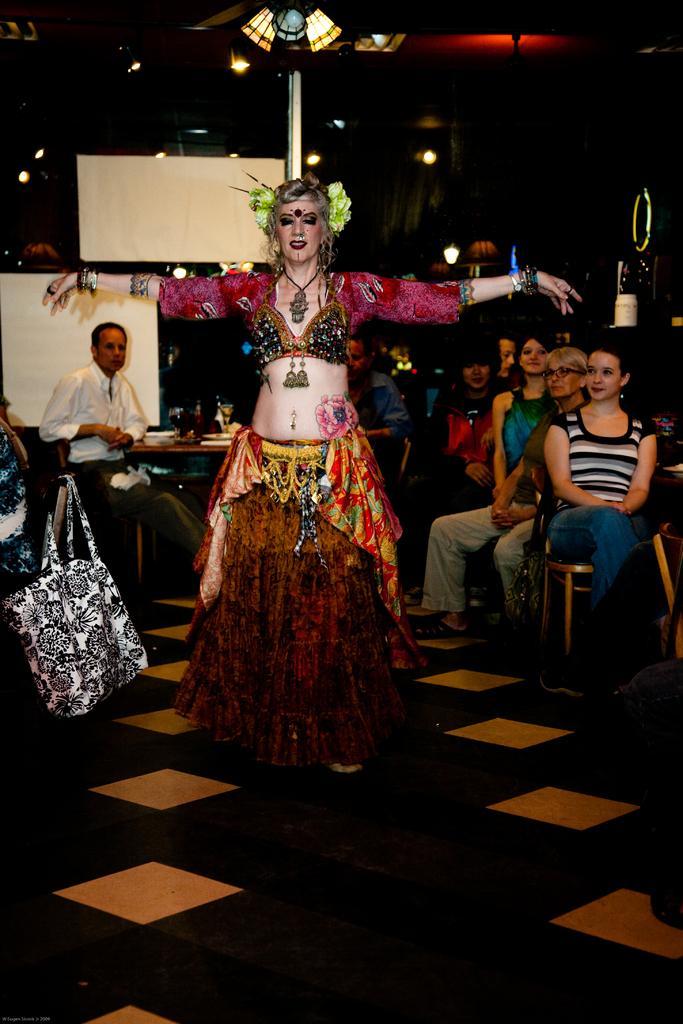Describe this image in one or two sentences. Woman standing,people are sitting on the chair,here there is bag. 